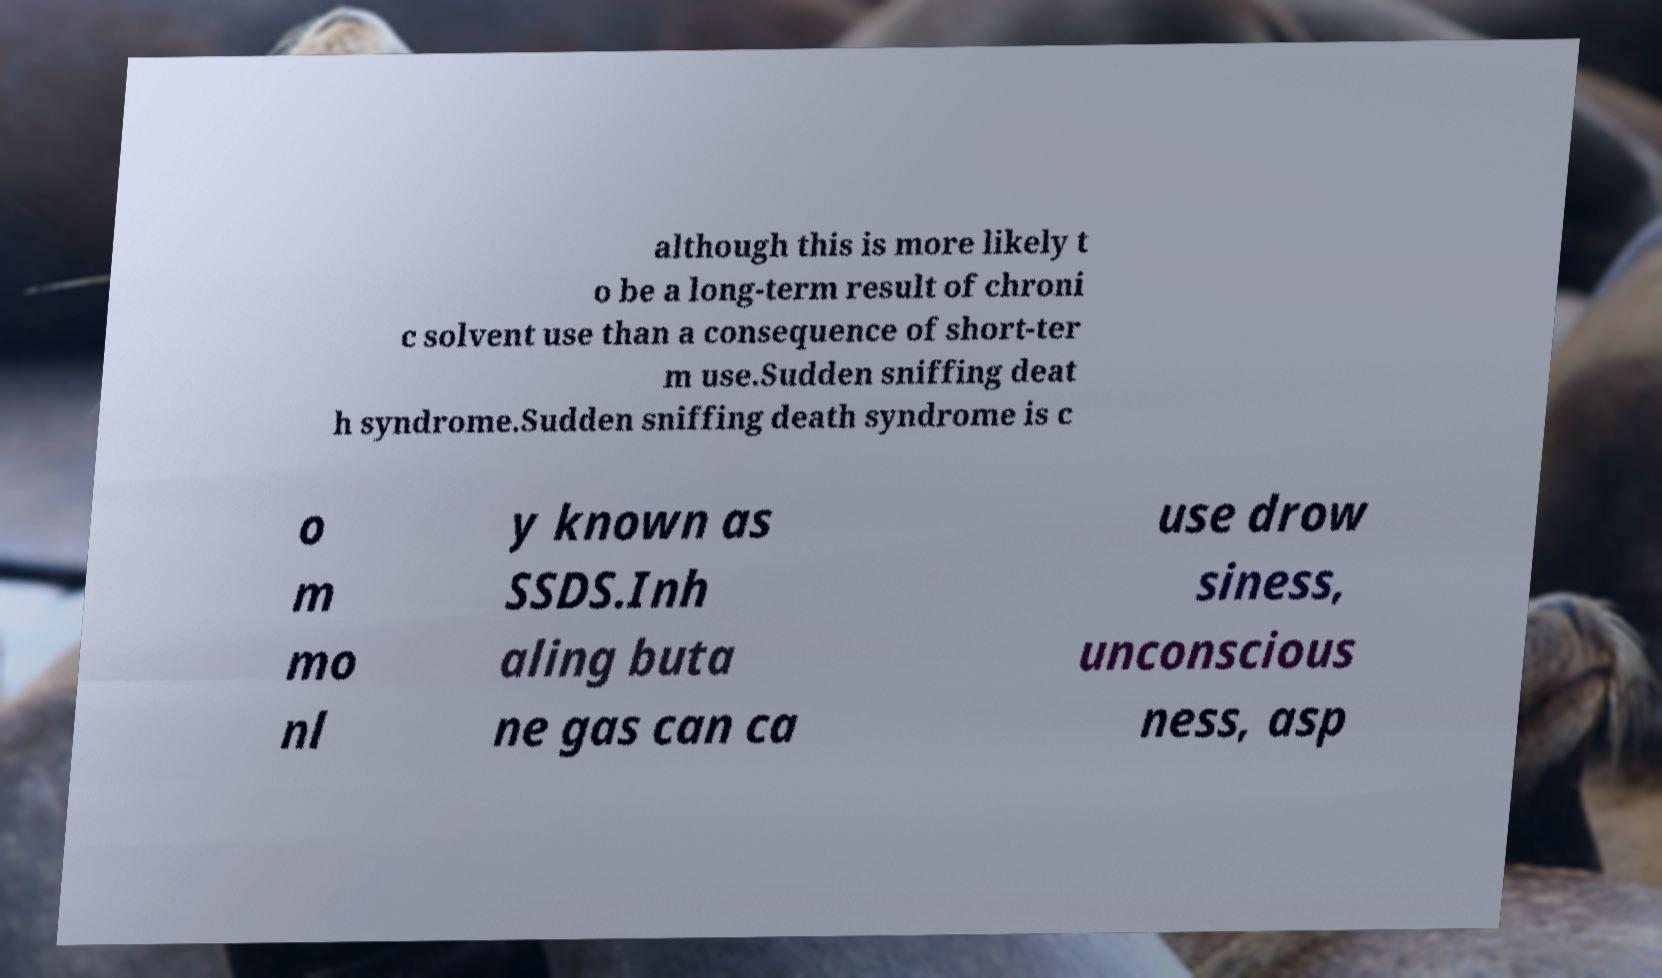For documentation purposes, I need the text within this image transcribed. Could you provide that? although this is more likely t o be a long-term result of chroni c solvent use than a consequence of short-ter m use.Sudden sniffing deat h syndrome.Sudden sniffing death syndrome is c o m mo nl y known as SSDS.Inh aling buta ne gas can ca use drow siness, unconscious ness, asp 